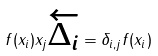<formula> <loc_0><loc_0><loc_500><loc_500>f ( x _ { i } ) x _ { j } \overleftarrow { \Delta _ { i } } = \delta _ { i , j } f ( x _ { i } )</formula> 